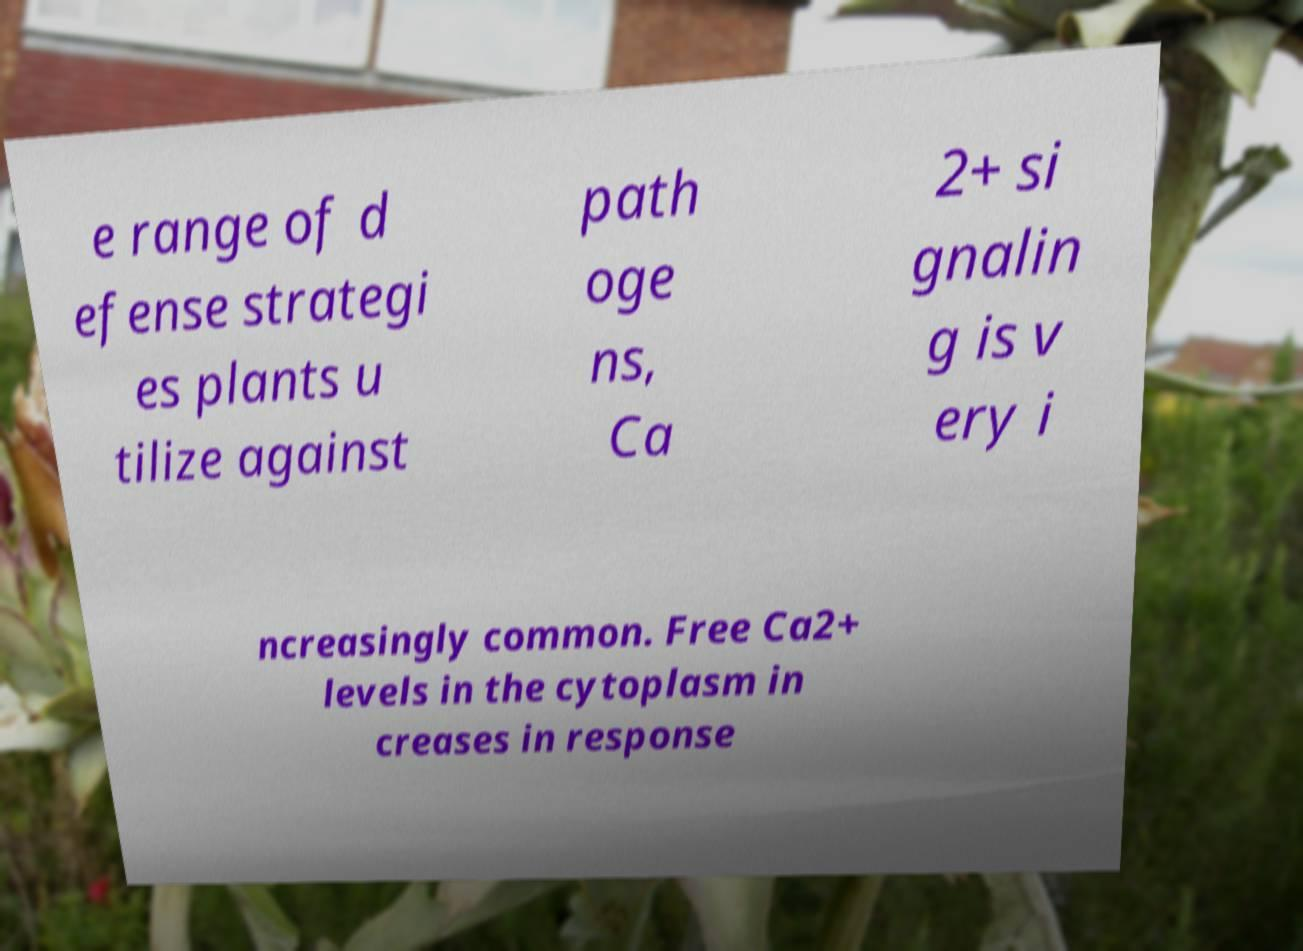Can you accurately transcribe the text from the provided image for me? e range of d efense strategi es plants u tilize against path oge ns, Ca 2+ si gnalin g is v ery i ncreasingly common. Free Ca2+ levels in the cytoplasm in creases in response 